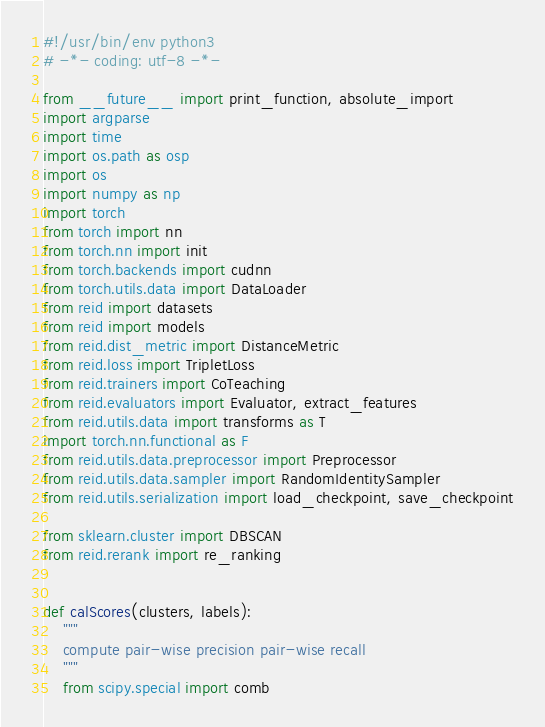Convert code to text. <code><loc_0><loc_0><loc_500><loc_500><_Python_>#!/usr/bin/env python3
# -*- coding: utf-8 -*-

from __future__ import print_function, absolute_import
import argparse
import time
import os.path as osp
import os
import numpy as np
import torch
from torch import nn
from torch.nn import init
from torch.backends import cudnn
from torch.utils.data import DataLoader
from reid import datasets
from reid import models
from reid.dist_metric import DistanceMetric
from reid.loss import TripletLoss
from reid.trainers import CoTeaching
from reid.evaluators import Evaluator, extract_features
from reid.utils.data import transforms as T
import torch.nn.functional as F
from reid.utils.data.preprocessor import Preprocessor
from reid.utils.data.sampler import RandomIdentitySampler
from reid.utils.serialization import load_checkpoint, save_checkpoint

from sklearn.cluster import DBSCAN
from reid.rerank import re_ranking


def calScores(clusters, labels):
    """
    compute pair-wise precision pair-wise recall
    """
    from scipy.special import comb</code> 